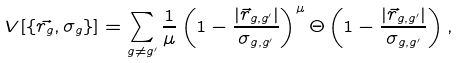<formula> <loc_0><loc_0><loc_500><loc_500>V [ \{ \vec { r _ { g } } , \sigma _ { g } \} ] = \sum _ { g \ne g ^ { \prime } } \frac { 1 } { \mu } \left ( 1 - \frac { | \vec { r } _ { g , g ^ { \prime } } | } { \sigma _ { g , g ^ { \prime } } } \right ) ^ { \mu } \Theta \left ( 1 - \frac { | \vec { r } _ { g , g ^ { \prime } } | } { \sigma _ { g , g ^ { \prime } } } \right ) ,</formula> 